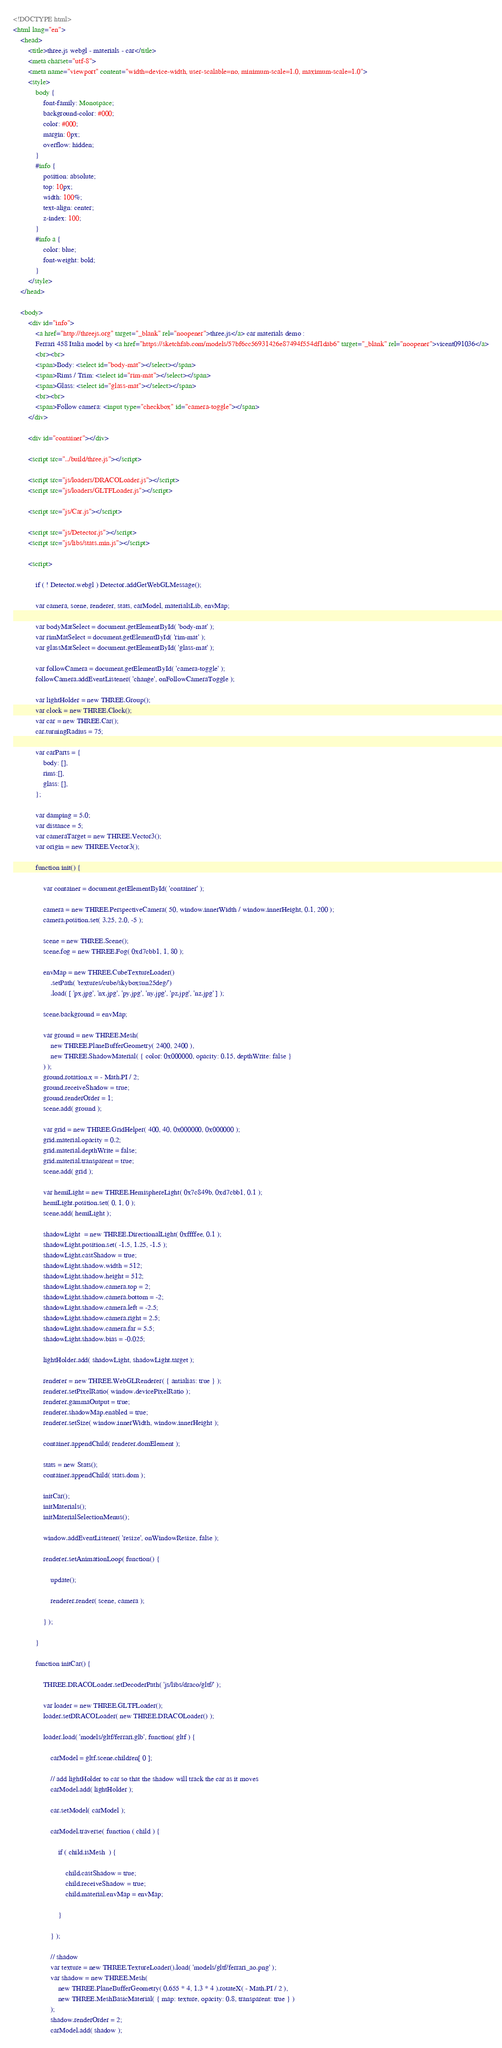Convert code to text. <code><loc_0><loc_0><loc_500><loc_500><_HTML_><!DOCTYPE html>
<html lang="en">
	<head>
		<title>three.js webgl - materials - car</title>
		<meta charset="utf-8">
		<meta name="viewport" content="width=device-width, user-scalable=no, minimum-scale=1.0, maximum-scale=1.0">
		<style>
			body {
				font-family: Monospace;
				background-color: #000;
				color: #000;
				margin: 0px;
				overflow: hidden;
			}
			#info {
				position: absolute;
				top: 10px;
				width: 100%;
				text-align: center;
				z-index: 100;
			}
			#info a {
				color: blue;
				font-weight: bold;
			}
		</style>
	</head>

	<body>
		<div id="info">
			<a href="http://threejs.org" target="_blank" rel="noopener">three.js</a> car materials demo :
			Ferrari 458 Italia model by <a href="https://sketchfab.com/models/57bf6cc56931426e87494f554df1dab6" target="_blank" rel="noopener">vicent091036</a>
			<br><br>
			<span>Body: <select id="body-mat"></select></span>
			<span>Rims / Trim: <select id="rim-mat"></select></span>
			<span>Glass: <select id="glass-mat"></select></span>
			<br><br>
			<span>Follow camera: <input type="checkbox" id="camera-toggle"></span>
		</div>

		<div id="container"></div>

		<script src="../build/three.js"></script>

		<script src="js/loaders/DRACOLoader.js"></script>
		<script src="js/loaders/GLTFLoader.js"></script>

		<script src="js/Car.js"></script>

		<script src="js/Detector.js"></script>
		<script src="js/libs/stats.min.js"></script>

		<script>

			if ( ! Detector.webgl ) Detector.addGetWebGLMessage();

			var camera, scene, renderer, stats, carModel, materialsLib, envMap;

			var bodyMatSelect = document.getElementById( 'body-mat' );
			var rimMatSelect = document.getElementById( 'rim-mat' );
			var glassMatSelect = document.getElementById( 'glass-mat' );

			var followCamera = document.getElementById( 'camera-toggle' );
			followCamera.addEventListener( 'change', onFollowCameraToggle );

			var lightHolder = new THREE.Group();
			var clock = new THREE.Clock();
			var car = new THREE.Car();
			car.turningRadius = 75;

			var carParts = {
				body: [],
				rims:[],
				glass: [],
			};

			var damping = 5.0;
			var distance = 5;
			var cameraTarget = new THREE.Vector3();
			var origin = new THREE.Vector3();

			function init() {

				var container = document.getElementById( 'container' );

				camera = new THREE.PerspectiveCamera( 50, window.innerWidth / window.innerHeight, 0.1, 200 );
				camera.position.set( 3.25, 2.0, -5 );

				scene = new THREE.Scene();
				scene.fog = new THREE.Fog( 0xd7cbb1, 1, 80 );

				envMap = new THREE.CubeTextureLoader()
					.setPath( 'textures/cube/skyboxsun25deg/')
					.load( [ 'px.jpg', 'nx.jpg', 'py.jpg', 'ny.jpg', 'pz.jpg', 'nz.jpg' ] );

				scene.background = envMap;

				var ground = new THREE.Mesh(
					new THREE.PlaneBufferGeometry( 2400, 2400 ),
					new THREE.ShadowMaterial( { color: 0x000000, opacity: 0.15, depthWrite: false }
				) );
				ground.rotation.x = - Math.PI / 2;
				ground.receiveShadow = true;
				ground.renderOrder = 1;
				scene.add( ground );

				var grid = new THREE.GridHelper( 400, 40, 0x000000, 0x000000 );
				grid.material.opacity = 0.2;
				grid.material.depthWrite = false;
				grid.material.transparent = true;
				scene.add( grid );

				var hemiLight = new THREE.HemisphereLight( 0x7c849b, 0xd7cbb1, 0.1 );
				hemiLight.position.set( 0, 1, 0 );
				scene.add( hemiLight );

				shadowLight  = new THREE.DirectionalLight( 0xffffee, 0.1 );
				shadowLight.position.set( -1.5, 1.25, -1.5 );
				shadowLight.castShadow = true;
				shadowLight.shadow.width = 512;
				shadowLight.shadow.height = 512;
				shadowLight.shadow.camera.top = 2;
				shadowLight.shadow.camera.bottom = -2;
				shadowLight.shadow.camera.left = -2.5;
				shadowLight.shadow.camera.right = 2.5;
				shadowLight.shadow.camera.far = 5.5;
				shadowLight.shadow.bias = -0.025;

				lightHolder.add( shadowLight, shadowLight.target );

				renderer = new THREE.WebGLRenderer( { antialias: true } );
				renderer.setPixelRatio( window.devicePixelRatio );
				renderer.gammaOutput = true;
				renderer.shadowMap.enabled = true;
				renderer.setSize( window.innerWidth, window.innerHeight );

				container.appendChild( renderer.domElement );

				stats = new Stats();
				container.appendChild( stats.dom );

				initCar();
				initMaterials();
				initMaterialSelectionMenus();

				window.addEventListener( 'resize', onWindowResize, false );

				renderer.setAnimationLoop( function() {

					update();

					renderer.render( scene, camera );

				} );

			}

			function initCar() {

				THREE.DRACOLoader.setDecoderPath( 'js/libs/draco/gltf/' );

				var loader = new THREE.GLTFLoader();
				loader.setDRACOLoader( new THREE.DRACOLoader() );

				loader.load( 'models/gltf/ferrari.glb', function( gltf ) {

					carModel = gltf.scene.children[ 0 ];

					// add lightHolder to car so that the shadow will track the car as it moves
					carModel.add( lightHolder );

					car.setModel( carModel );

					carModel.traverse( function ( child ) {

						if ( child.isMesh  ) {

							child.castShadow = true;
							child.receiveShadow = true;
							child.material.envMap = envMap;

						}

					} );

					// shadow
					var texture = new THREE.TextureLoader().load( 'models/gltf/ferrari_ao.png' );
					var shadow = new THREE.Mesh(
						new THREE.PlaneBufferGeometry( 0.655 * 4, 1.3 * 4 ).rotateX( - Math.PI / 2 ),
						new THREE.MeshBasicMaterial( { map: texture, opacity: 0.8, transparent: true } )
					);
					shadow.renderOrder = 2;
					carModel.add( shadow );
</code> 